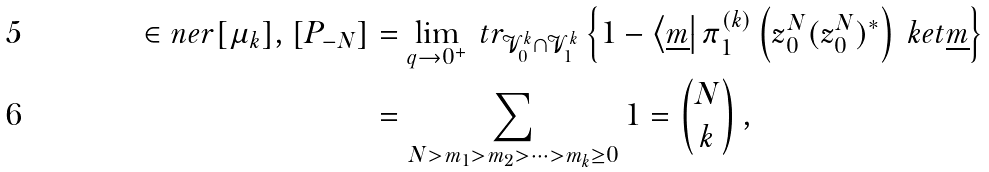Convert formula to latex. <formula><loc_0><loc_0><loc_500><loc_500>\in n e r { [ \mu _ { k } ] , [ P _ { - N } ] } & = \lim _ { q \to 0 ^ { + } } \ t r _ { \mathcal { V } ^ { k } _ { 0 } \cap \mathcal { V } ^ { k } _ { 1 } } \left \{ 1 - \left < \underline { m } \right | \pi ^ { ( k ) } _ { 1 } \left ( z _ { 0 } ^ { N } ( z _ { 0 } ^ { N } ) ^ { * } \right ) \ k e t { \underline { m } } \right \} \\ & = \sum _ { N > m _ { 1 } > m _ { 2 } > \dots > m _ { k } \geq 0 } 1 = \binom { N } { k } \, ,</formula> 